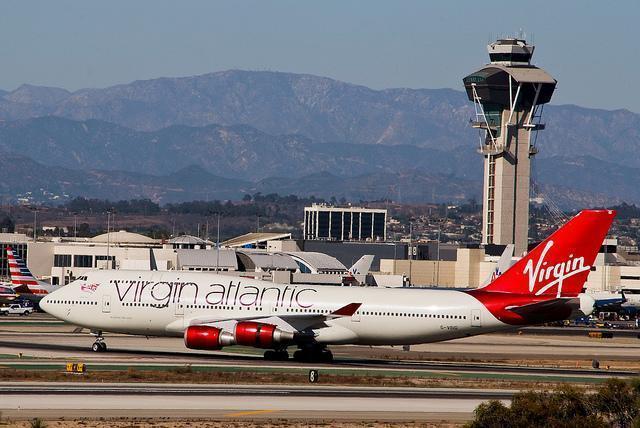What famous billionaire started the Virgin airline company?
Select the accurate answer and provide justification: `Answer: choice
Rationale: srationale.`
Options: Donald trump, sam walton, richard branson, michael bloomberg. Answer: richard branson.
Rationale: His name is richard. Who owns the company whose name appears here?
Select the correct answer and articulate reasoning with the following format: 'Answer: answer
Rationale: rationale.'
Options: Eli whitney, richard branson, juan borgia, will smith. Answer: richard branson.
Rationale: The airline company's name is written on the side. the man who owns the airline is internet searchable. 